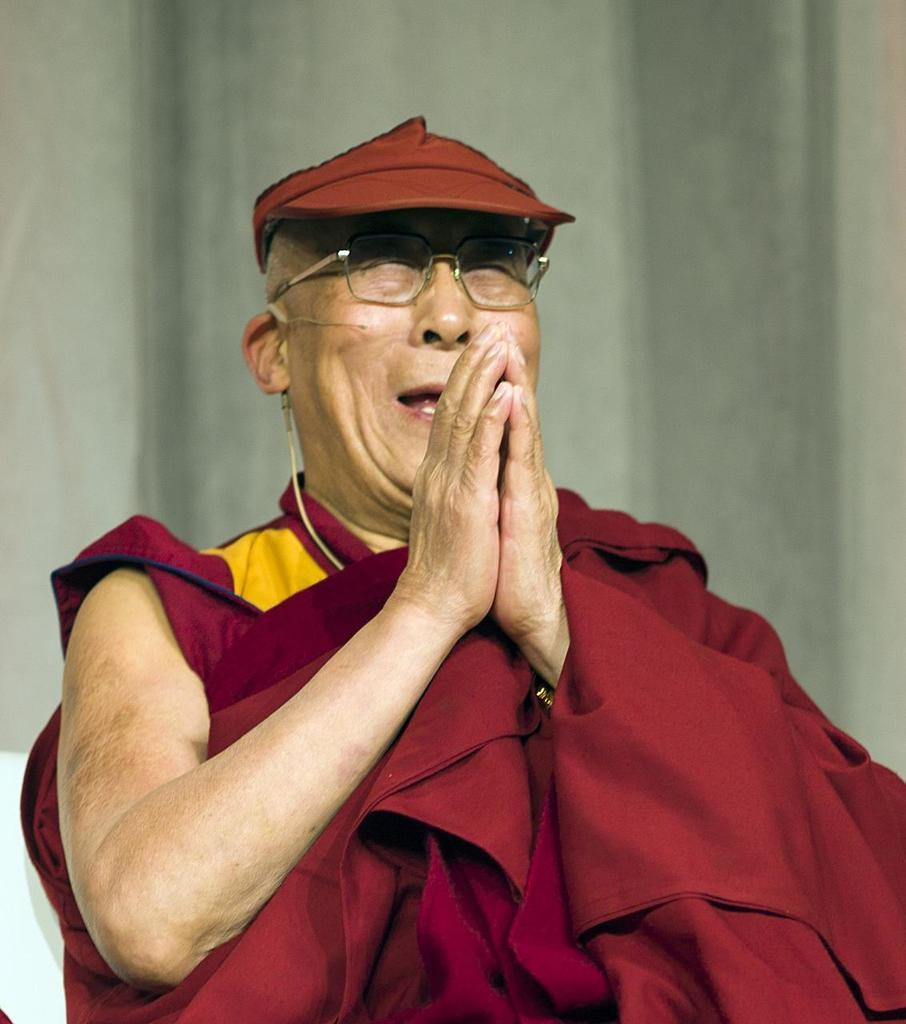Who is the main subject in the image? There is an old monk in the image. What is the monk wearing? The monk is wearing a maroon dress and a cap. What is the monk doing in the image? The monk is praying. What can be seen in the background of the image? There is a wall in the background of the image. What type of gold beam is the monk holding in the image? There is no gold beam present in the image; the monk is simply praying and wearing a maroon dress and cap. 